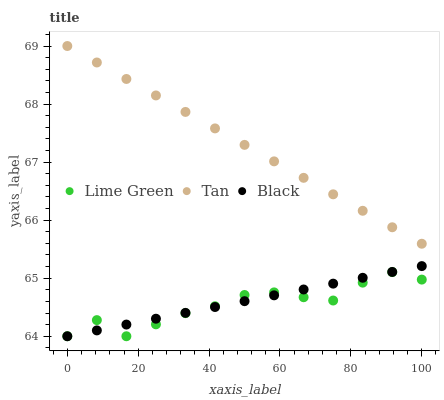Does Lime Green have the minimum area under the curve?
Answer yes or no. Yes. Does Tan have the maximum area under the curve?
Answer yes or no. Yes. Does Tan have the minimum area under the curve?
Answer yes or no. No. Does Lime Green have the maximum area under the curve?
Answer yes or no. No. Is Black the smoothest?
Answer yes or no. Yes. Is Lime Green the roughest?
Answer yes or no. Yes. Is Tan the smoothest?
Answer yes or no. No. Is Tan the roughest?
Answer yes or no. No. Does Black have the lowest value?
Answer yes or no. Yes. Does Tan have the lowest value?
Answer yes or no. No. Does Tan have the highest value?
Answer yes or no. Yes. Does Lime Green have the highest value?
Answer yes or no. No. Is Black less than Tan?
Answer yes or no. Yes. Is Tan greater than Black?
Answer yes or no. Yes. Does Black intersect Lime Green?
Answer yes or no. Yes. Is Black less than Lime Green?
Answer yes or no. No. Is Black greater than Lime Green?
Answer yes or no. No. Does Black intersect Tan?
Answer yes or no. No. 